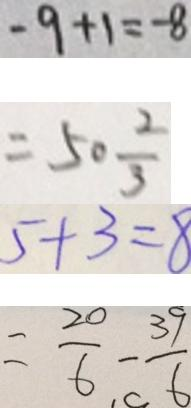Convert formula to latex. <formula><loc_0><loc_0><loc_500><loc_500>- 9 + 1 = - 8 
 = 5 0 \frac { 2 } { 3 } 
 5 + 3 = 8 
 = \frac { 2 0 } { 6 } - \frac { 3 9 } { 6 }</formula> 